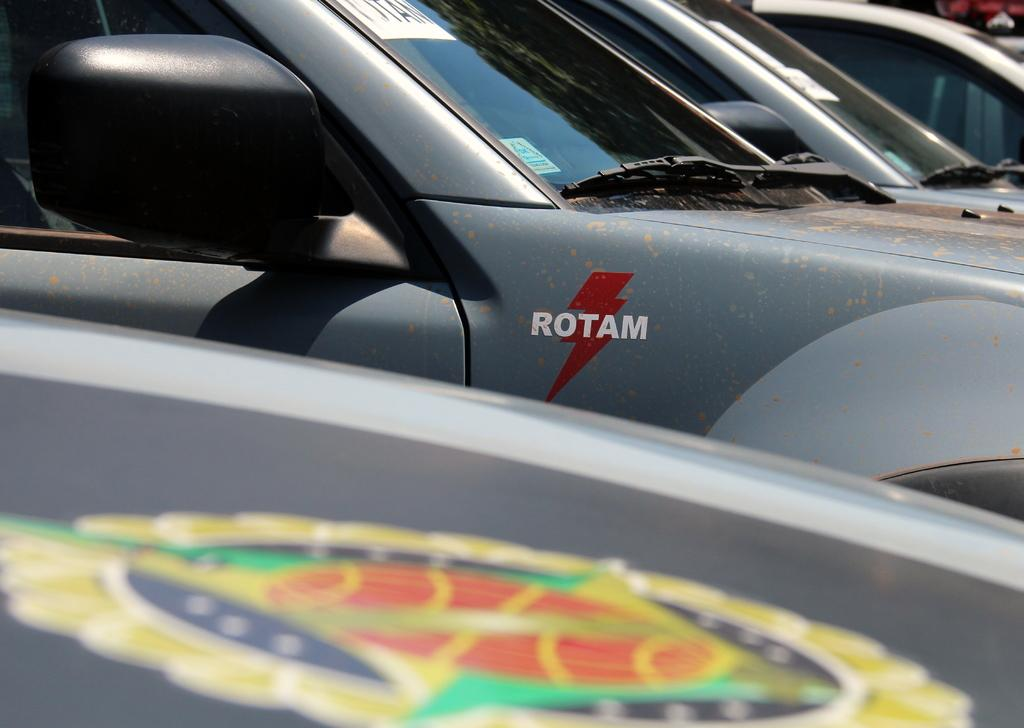What types of objects can be seen in the image? There are vehicles in the image. Can you describe the vehicles in the image? Unfortunately, the provided facts do not give any specific details about the vehicles. How many vehicles are present in the image? The number of vehicles in the image cannot be determined from the given facts. Are there any flames coming out of the vehicles in the image? There is no mention of flames in the provided facts, and therefore we cannot determine if there are any flames in the image. Can you see any volcanoes in the image? There is no mention of volcanoes in the provided facts, and therefore we cannot determine if there are any volcanoes in the image. How many dogs are present in the image? There is no mention of dogs in the provided facts, and therefore we cannot determine if there are any dogs in the image. 